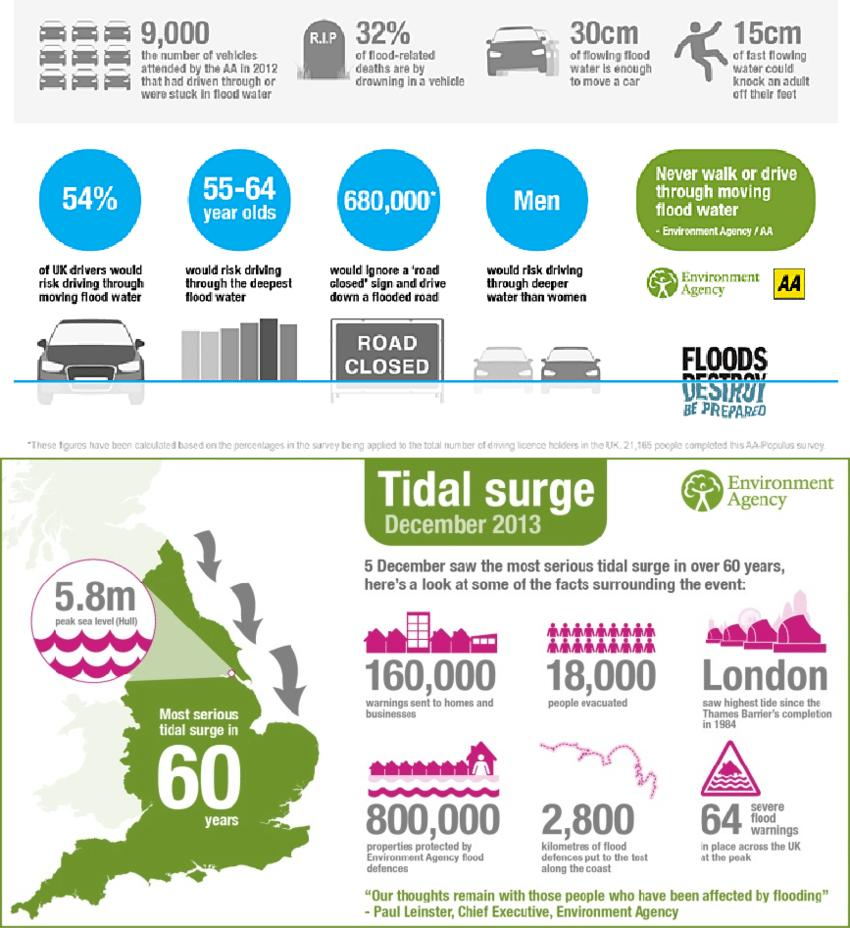Identify some key points in this picture. According to data, 32% of flood-related deaths result from drowning in a vehicle. In 2012, approximately 9,000 vehicles had driven through or been stranded in flood waters. The Environment Agency protected approximately 800,000 properties from flood damage through the use of its flood defenses. A study revealed that 680,000 individuals would recklessly drive down a flooded road despite a "road closed" sign being present. It is estimated that flowing flood water with a height of 30 centimeters is sufficient to move a car. 